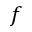Convert formula to latex. <formula><loc_0><loc_0><loc_500><loc_500>f</formula> 